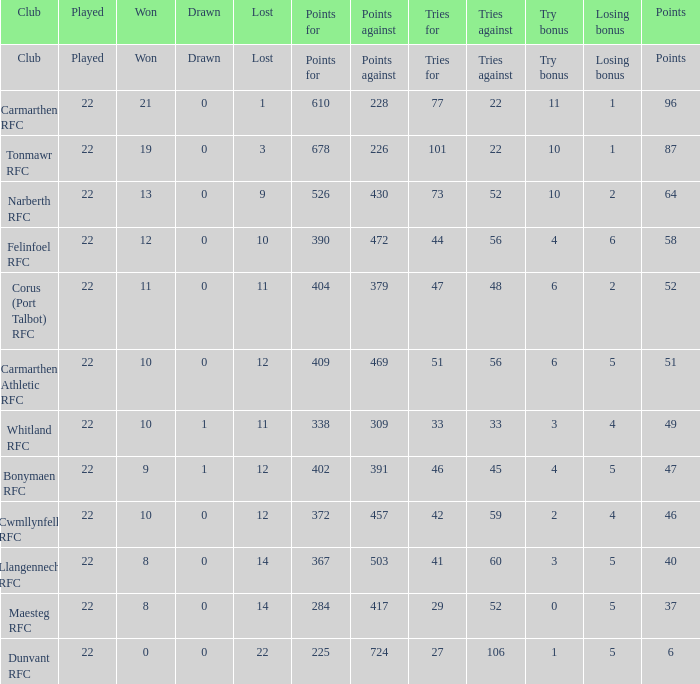Identify the disadvantages for 51 points. 469.0. 